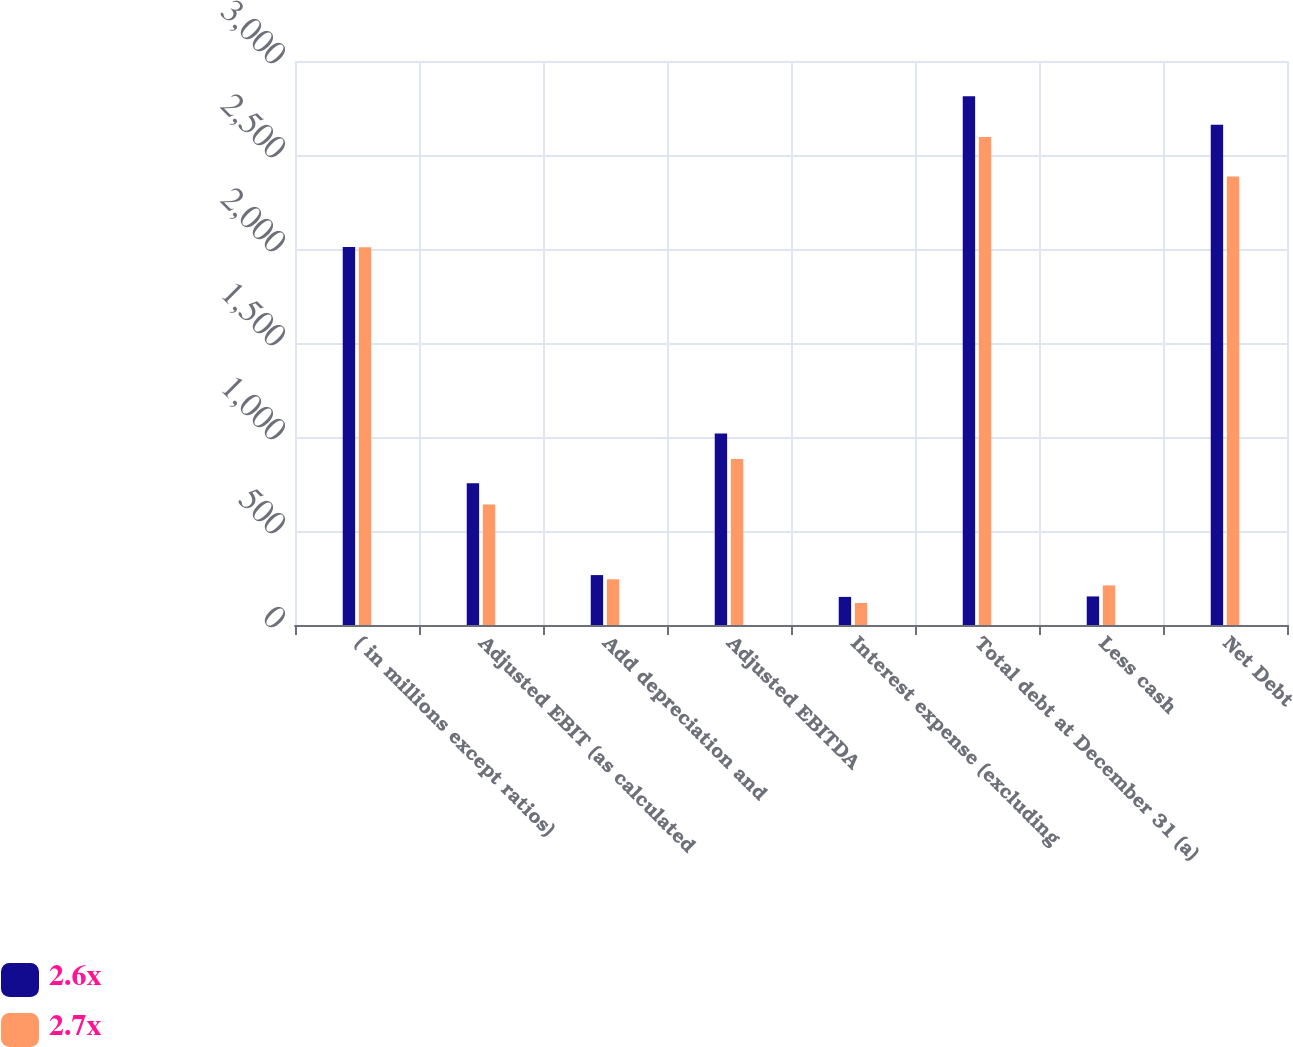Convert chart. <chart><loc_0><loc_0><loc_500><loc_500><stacked_bar_chart><ecel><fcel>( in millions except ratios)<fcel>Adjusted EBIT (as calculated<fcel>Add depreciation and<fcel>Adjusted EBITDA<fcel>Interest expense (excluding<fcel>Total debt at December 31 (a)<fcel>Less cash<fcel>Net Debt<nl><fcel>2.6x<fcel>2010<fcel>753.6<fcel>265.5<fcel>1019.1<fcel>149.4<fcel>2812.3<fcel>152<fcel>2660.3<nl><fcel>2.7x<fcel>2009<fcel>640.4<fcel>243.1<fcel>883.5<fcel>117.2<fcel>2596.2<fcel>210.6<fcel>2385.6<nl></chart> 